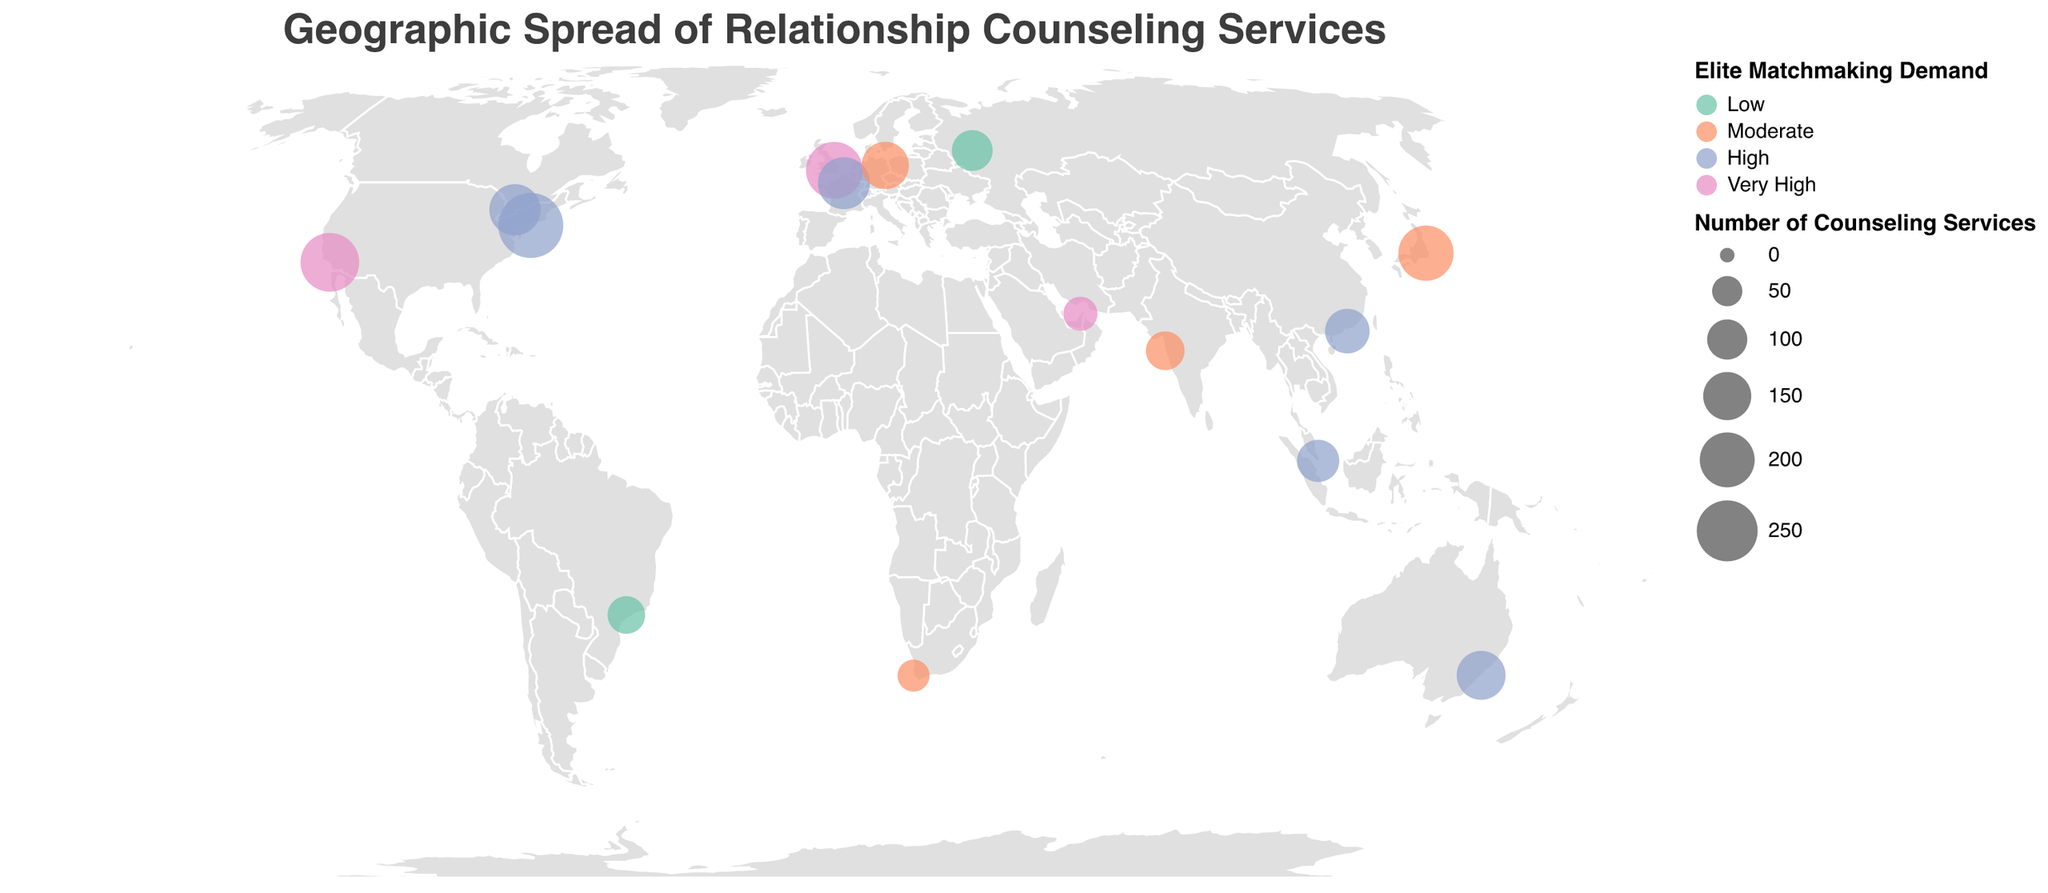What is the title of the figure? The title is displayed at the top of the figure in a larger font, clearly stating the subject.
Answer: Geographic Spread of Relationship Counseling Services Which city has the highest number of relationship counseling services? By looking at the sizes of the circles, the largest circle indicates the highest number of counseling services. The largest circle is over New York.
Answer: New York Which cities have a "Very High" demand for elite matchmaking services? The color legend indicates "Very High" is represented by pink. Identify the cities with pink circles. These cities are London, Dubai, and Los Angeles.
Answer: London, Dubai, Los Angeles How does the number of counseling services in Los Angeles compare to that in Tokyo? By comparing the circle sizes of Los Angeles and Tokyo, Los Angeles has a larger circle implying a higher number of services.
Answer: Los Angeles has more counseling services than Tokyo Which city has the lowest number of relationship counseling services, and what is its elite matchmaking demand level? The smallest circle on the plot corresponds to Cape Town. The color of this circle, represented in orange, shows a "Moderate" level of elite matchmaking demand.
Answer: Cape Town, Moderate What is the difference between the number of relationship counseling services in Berlin and Sydney? Berlin has 145 counseling services while Sydney has 156. The difference is obtained by subtracting 145 from 156.
Answer: 11 What are the respective elite matchmaking demand levels for New York, London, and Paris? By identifying the color of the circles for these cities: New York is blue ("High"), London is pink ("Very High"), and Paris is blue ("High").
Answer: New York: High, London: Very High, Paris: High In terms of the number of counseling services, which city ranks fourth and what is its elite matchmaking demand level? Looking at the circle sizes, the fourth largest appears to be Tokyo. The color of the circle representing Tokyo shows "Moderate" demand for elite matchmaking services.
Answer: Tokyo, Moderate Which continents have the cities with "Very High" elite matchmaking demand? Identify the colors representing "Very High" demand and check their locations: North America (Los Angeles), Europe (London), and Asia (Dubai).
Answer: North America, Europe, Asia How many cities in the data have a "Moderate" level of elite matchmaking demand, and can you name them? Cities with "Moderate" demand are represented in orange. By counting and naming them: Tokyo, Mumbai, Berlin, Cape Town.
Answer: 4, Tokyo, Mumbai, Berlin, Cape Town 